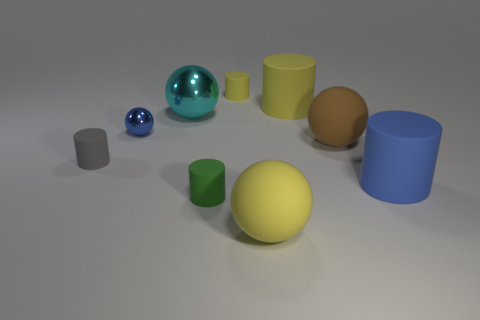Are there any other metallic spheres that have the same color as the big metallic ball?
Offer a terse response. No. How many matte things are tiny gray cylinders or cyan cubes?
Your answer should be compact. 1. There is a big blue thing in front of the big brown object; what number of large yellow matte things are in front of it?
Give a very brief answer. 1. How many large balls have the same material as the small ball?
Keep it short and to the point. 1. What number of large objects are green rubber objects or metal spheres?
Provide a succinct answer. 1. There is a matte thing that is both behind the gray object and in front of the blue ball; what is its shape?
Ensure brevity in your answer.  Sphere. Do the small gray cylinder and the big blue thing have the same material?
Offer a terse response. Yes. There is a metal sphere that is the same size as the gray rubber cylinder; what is its color?
Your answer should be compact. Blue. What color is the tiny thing that is on the right side of the tiny shiny thing and behind the brown ball?
Your response must be concise. Yellow. What is the size of the rubber object that is the same color as the small metallic thing?
Make the answer very short. Large. 